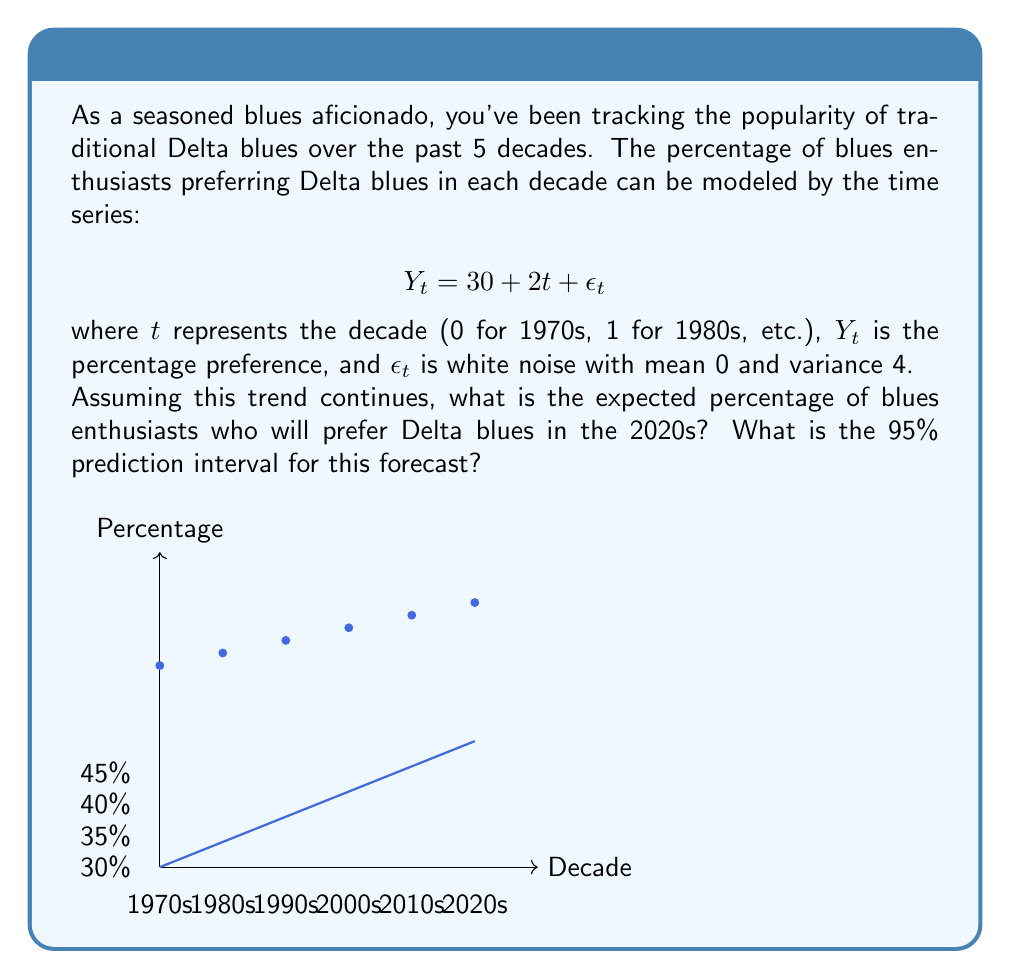Can you solve this math problem? Let's approach this step-by-step:

1) The model is given as $Y_t = 30 + 2t + \epsilon_t$

2) For the 2020s, $t = 5$ (as we start counting from 0 for the 1970s)

3) To find the expected percentage, we ignore the error term $\epsilon_t$ as its expected value is 0:

   $E(Y_5) = 30 + 2(5) = 30 + 10 = 40$

4) For the prediction interval, we need to consider the variance of the forecast error. The variance of $Y_t$ is equal to the variance of $\epsilon_t$, which is 4.

5) For a 95% prediction interval, we use 1.96 standard deviations (assuming normality):

   $1.96 \times \sqrt{4} = 1.96 \times 2 = 3.92$

6) The prediction interval is therefore:

   $40 \pm 3.92$

   Lower bound: $40 - 3.92 = 36.08$
   Upper bound: $40 + 3.92 = 43.92$
Answer: Expected percentage: 40%. 95% Prediction Interval: (36.08%, 43.92%) 